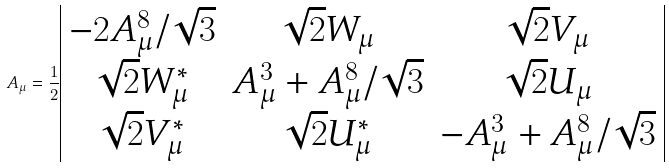Convert formula to latex. <formula><loc_0><loc_0><loc_500><loc_500>A _ { \mu } = \frac { 1 } { 2 } \begin{array} { | c c c | } - 2 A _ { \mu } ^ { 8 } / \sqrt { 3 } & \sqrt { 2 } W _ { \mu } & \sqrt { 2 } V _ { \mu } \\ \sqrt { 2 } W _ { \mu } ^ { * } & A _ { \mu } ^ { 3 } + A _ { \mu } ^ { 8 } / \sqrt { 3 } & \sqrt { 2 } U _ { \mu } \\ \sqrt { 2 } V _ { \mu } ^ { * } & \sqrt { 2 } U _ { \mu } ^ { * } & - A _ { \mu } ^ { 3 } + A _ { \mu } ^ { 8 } / \sqrt { 3 } \\ \end{array}</formula> 